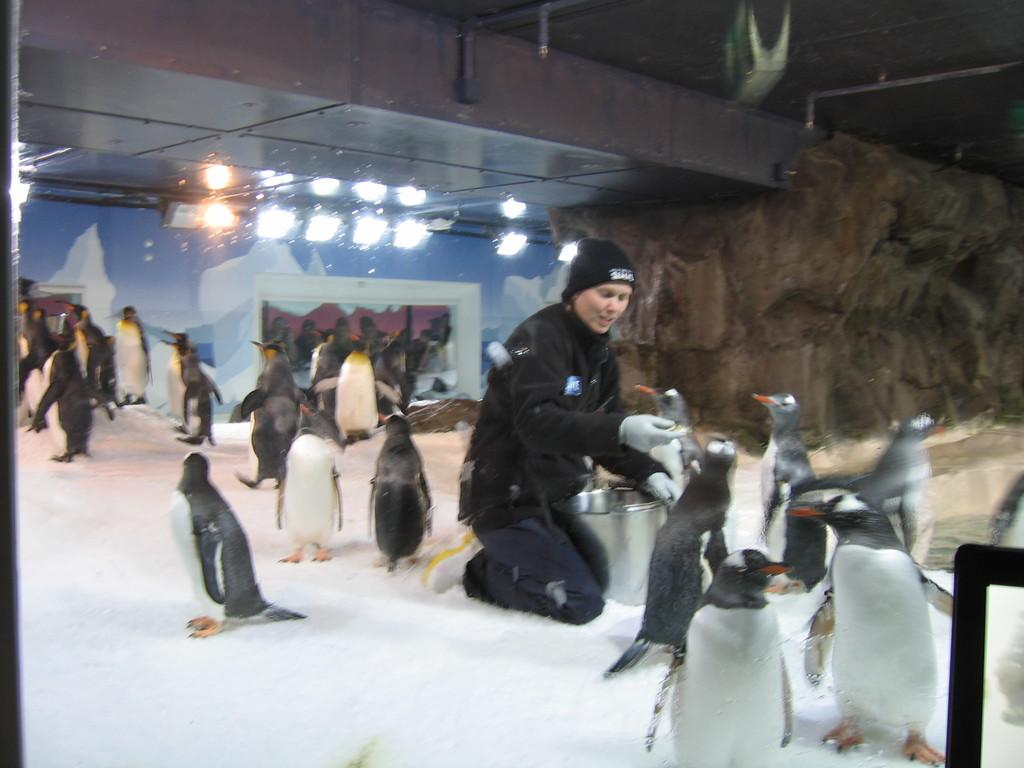Who or what is present in the image? There is a person and penguins in the image. What is the setting of the image? The person and penguins are in snow. Can you describe the distribution of penguins in the image? The penguins are present in multiple locations within the image. What type of wave can be seen in the image? There is no wave present in the image; it features a person and penguins in snow. Is there an umbrella visible in the image? No, there is no umbrella present in the image. 